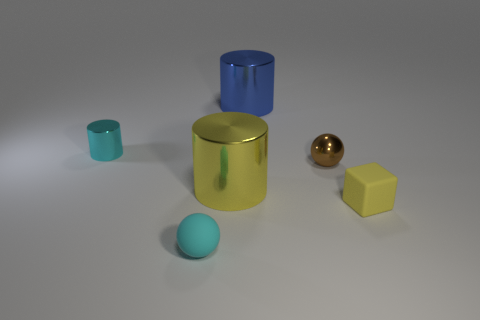There is a matte thing that is the same size as the matte block; what is its shape? sphere 